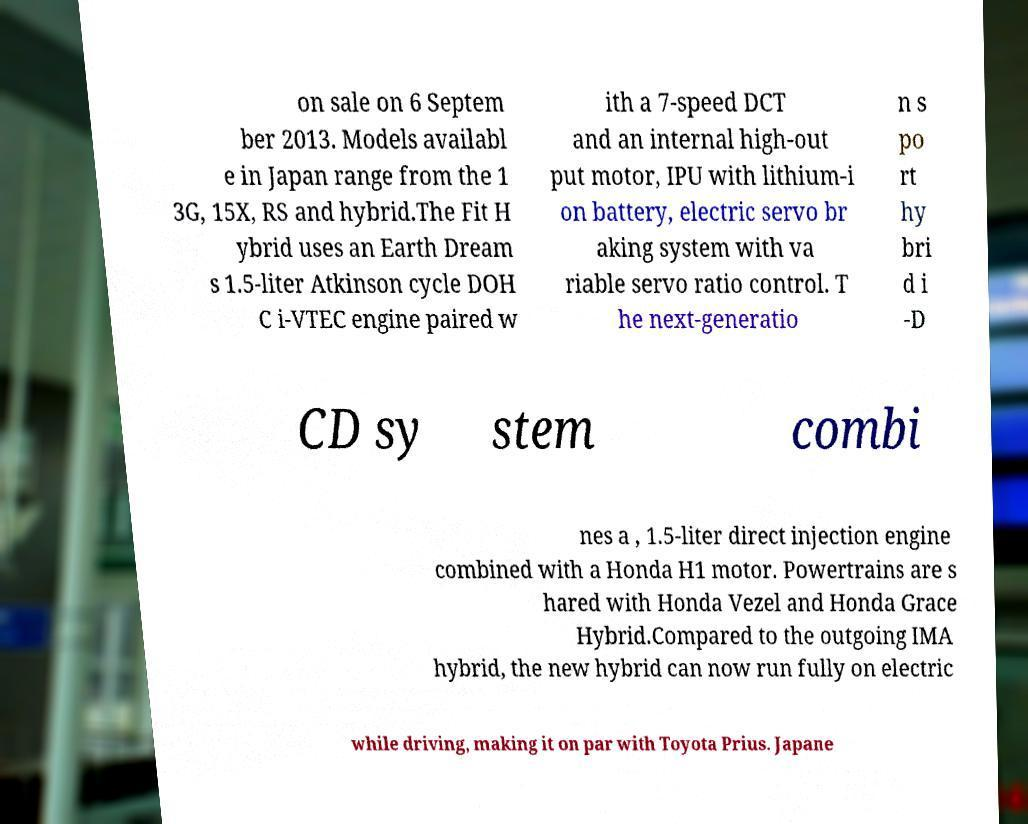There's text embedded in this image that I need extracted. Can you transcribe it verbatim? on sale on 6 Septem ber 2013. Models availabl e in Japan range from the 1 3G, 15X, RS and hybrid.The Fit H ybrid uses an Earth Dream s 1.5-liter Atkinson cycle DOH C i-VTEC engine paired w ith a 7-speed DCT and an internal high-out put motor, IPU with lithium-i on battery, electric servo br aking system with va riable servo ratio control. T he next-generatio n s po rt hy bri d i -D CD sy stem combi nes a , 1.5-liter direct injection engine combined with a Honda H1 motor. Powertrains are s hared with Honda Vezel and Honda Grace Hybrid.Compared to the outgoing IMA hybrid, the new hybrid can now run fully on electric while driving, making it on par with Toyota Prius. Japane 